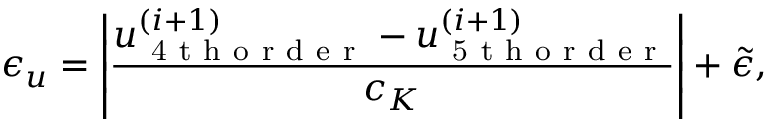<formula> <loc_0><loc_0><loc_500><loc_500>\epsilon _ { u } = \left | \frac { u _ { 4 t h o r d e r } ^ { ( i + 1 ) } - u _ { 5 t h o r d e r } ^ { ( i + 1 ) } } { c _ { K } } \right | + \tilde { \epsilon } ,</formula> 